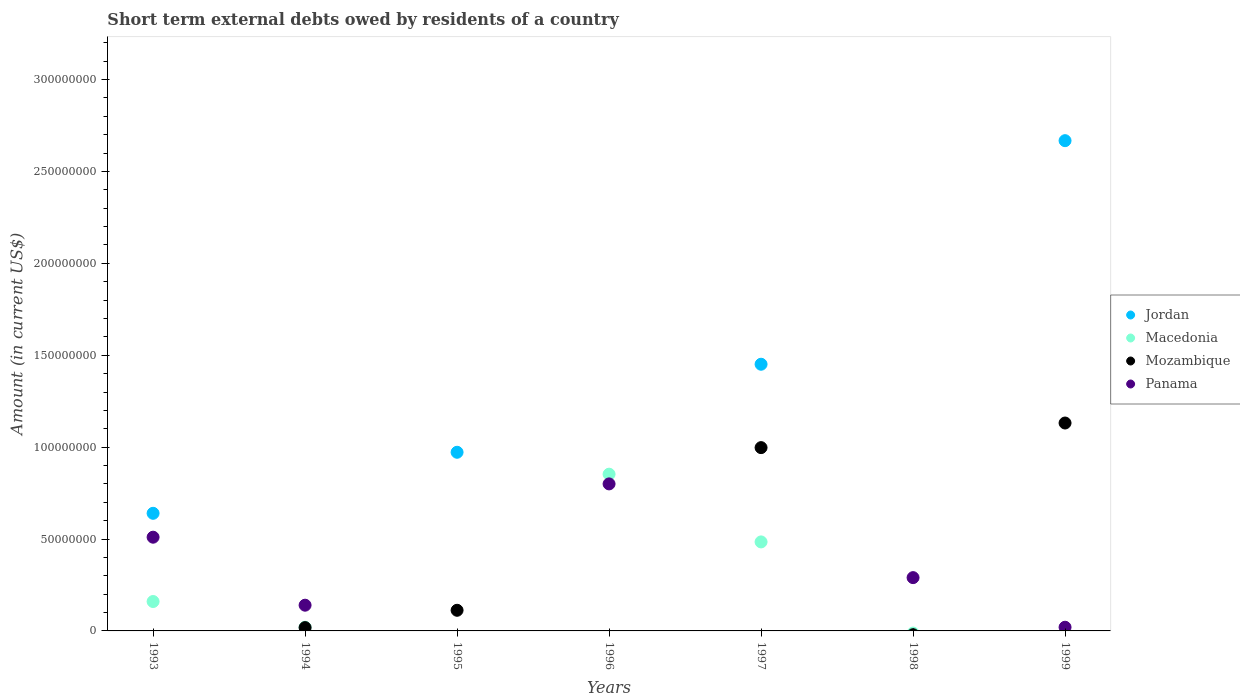How many different coloured dotlines are there?
Provide a succinct answer. 4. Across all years, what is the maximum amount of short-term external debts owed by residents in Panama?
Offer a terse response. 8.00e+07. What is the total amount of short-term external debts owed by residents in Jordan in the graph?
Make the answer very short. 5.73e+08. What is the difference between the amount of short-term external debts owed by residents in Mozambique in 1995 and that in 1997?
Your answer should be very brief. -8.85e+07. What is the difference between the amount of short-term external debts owed by residents in Macedonia in 1994 and the amount of short-term external debts owed by residents in Mozambique in 1999?
Offer a very short reply. -1.11e+08. What is the average amount of short-term external debts owed by residents in Jordan per year?
Ensure brevity in your answer.  8.19e+07. In the year 1995, what is the difference between the amount of short-term external debts owed by residents in Mozambique and amount of short-term external debts owed by residents in Jordan?
Keep it short and to the point. -8.60e+07. Is the difference between the amount of short-term external debts owed by residents in Mozambique in 1995 and 1997 greater than the difference between the amount of short-term external debts owed by residents in Jordan in 1995 and 1997?
Keep it short and to the point. No. What is the difference between the highest and the second highest amount of short-term external debts owed by residents in Jordan?
Keep it short and to the point. 1.22e+08. What is the difference between the highest and the lowest amount of short-term external debts owed by residents in Macedonia?
Offer a very short reply. 8.53e+07. In how many years, is the amount of short-term external debts owed by residents in Jordan greater than the average amount of short-term external debts owed by residents in Jordan taken over all years?
Ensure brevity in your answer.  3. Is the sum of the amount of short-term external debts owed by residents in Panama in 1996 and 1999 greater than the maximum amount of short-term external debts owed by residents in Mozambique across all years?
Give a very brief answer. No. Is it the case that in every year, the sum of the amount of short-term external debts owed by residents in Mozambique and amount of short-term external debts owed by residents in Macedonia  is greater than the amount of short-term external debts owed by residents in Jordan?
Your answer should be compact. No. Does the amount of short-term external debts owed by residents in Mozambique monotonically increase over the years?
Your answer should be compact. No. Is the amount of short-term external debts owed by residents in Mozambique strictly less than the amount of short-term external debts owed by residents in Jordan over the years?
Your answer should be very brief. No. How many dotlines are there?
Ensure brevity in your answer.  4. How many years are there in the graph?
Provide a short and direct response. 7. What is the difference between two consecutive major ticks on the Y-axis?
Offer a very short reply. 5.00e+07. Does the graph contain any zero values?
Provide a succinct answer. Yes. Does the graph contain grids?
Your answer should be compact. No. Where does the legend appear in the graph?
Offer a very short reply. Center right. How are the legend labels stacked?
Make the answer very short. Vertical. What is the title of the graph?
Your response must be concise. Short term external debts owed by residents of a country. Does "Chad" appear as one of the legend labels in the graph?
Give a very brief answer. No. What is the label or title of the X-axis?
Your response must be concise. Years. What is the label or title of the Y-axis?
Provide a short and direct response. Amount (in current US$). What is the Amount (in current US$) of Jordan in 1993?
Offer a terse response. 6.40e+07. What is the Amount (in current US$) of Macedonia in 1993?
Your answer should be compact. 1.60e+07. What is the Amount (in current US$) in Mozambique in 1993?
Make the answer very short. 0. What is the Amount (in current US$) of Panama in 1993?
Your response must be concise. 5.10e+07. What is the Amount (in current US$) of Macedonia in 1994?
Your answer should be compact. 2.00e+06. What is the Amount (in current US$) of Mozambique in 1994?
Offer a terse response. 1.80e+06. What is the Amount (in current US$) of Panama in 1994?
Offer a very short reply. 1.40e+07. What is the Amount (in current US$) of Jordan in 1995?
Provide a succinct answer. 9.72e+07. What is the Amount (in current US$) of Mozambique in 1995?
Provide a succinct answer. 1.12e+07. What is the Amount (in current US$) in Macedonia in 1996?
Ensure brevity in your answer.  8.53e+07. What is the Amount (in current US$) in Mozambique in 1996?
Ensure brevity in your answer.  0. What is the Amount (in current US$) of Panama in 1996?
Your response must be concise. 8.00e+07. What is the Amount (in current US$) of Jordan in 1997?
Offer a very short reply. 1.45e+08. What is the Amount (in current US$) in Macedonia in 1997?
Offer a terse response. 4.84e+07. What is the Amount (in current US$) in Mozambique in 1997?
Your response must be concise. 9.97e+07. What is the Amount (in current US$) of Mozambique in 1998?
Your answer should be compact. 0. What is the Amount (in current US$) of Panama in 1998?
Your answer should be very brief. 2.90e+07. What is the Amount (in current US$) in Jordan in 1999?
Your response must be concise. 2.67e+08. What is the Amount (in current US$) in Macedonia in 1999?
Make the answer very short. 0. What is the Amount (in current US$) of Mozambique in 1999?
Your answer should be compact. 1.13e+08. Across all years, what is the maximum Amount (in current US$) of Jordan?
Offer a very short reply. 2.67e+08. Across all years, what is the maximum Amount (in current US$) in Macedonia?
Make the answer very short. 8.53e+07. Across all years, what is the maximum Amount (in current US$) in Mozambique?
Your response must be concise. 1.13e+08. Across all years, what is the maximum Amount (in current US$) of Panama?
Provide a succinct answer. 8.00e+07. Across all years, what is the minimum Amount (in current US$) of Mozambique?
Give a very brief answer. 0. Across all years, what is the minimum Amount (in current US$) in Panama?
Provide a succinct answer. 0. What is the total Amount (in current US$) of Jordan in the graph?
Offer a terse response. 5.73e+08. What is the total Amount (in current US$) of Macedonia in the graph?
Provide a short and direct response. 1.52e+08. What is the total Amount (in current US$) of Mozambique in the graph?
Your answer should be compact. 2.26e+08. What is the total Amount (in current US$) of Panama in the graph?
Provide a short and direct response. 1.76e+08. What is the difference between the Amount (in current US$) in Macedonia in 1993 and that in 1994?
Give a very brief answer. 1.40e+07. What is the difference between the Amount (in current US$) in Panama in 1993 and that in 1994?
Your response must be concise. 3.70e+07. What is the difference between the Amount (in current US$) of Jordan in 1993 and that in 1995?
Offer a terse response. -3.32e+07. What is the difference between the Amount (in current US$) of Macedonia in 1993 and that in 1996?
Provide a succinct answer. -6.93e+07. What is the difference between the Amount (in current US$) of Panama in 1993 and that in 1996?
Keep it short and to the point. -2.90e+07. What is the difference between the Amount (in current US$) of Jordan in 1993 and that in 1997?
Give a very brief answer. -8.11e+07. What is the difference between the Amount (in current US$) in Macedonia in 1993 and that in 1997?
Your answer should be compact. -3.24e+07. What is the difference between the Amount (in current US$) of Panama in 1993 and that in 1998?
Offer a terse response. 2.20e+07. What is the difference between the Amount (in current US$) of Jordan in 1993 and that in 1999?
Your answer should be very brief. -2.03e+08. What is the difference between the Amount (in current US$) of Panama in 1993 and that in 1999?
Provide a succinct answer. 4.90e+07. What is the difference between the Amount (in current US$) in Mozambique in 1994 and that in 1995?
Provide a short and direct response. -9.43e+06. What is the difference between the Amount (in current US$) of Macedonia in 1994 and that in 1996?
Your answer should be compact. -8.33e+07. What is the difference between the Amount (in current US$) of Panama in 1994 and that in 1996?
Offer a very short reply. -6.60e+07. What is the difference between the Amount (in current US$) of Macedonia in 1994 and that in 1997?
Make the answer very short. -4.64e+07. What is the difference between the Amount (in current US$) in Mozambique in 1994 and that in 1997?
Ensure brevity in your answer.  -9.79e+07. What is the difference between the Amount (in current US$) of Panama in 1994 and that in 1998?
Your answer should be compact. -1.50e+07. What is the difference between the Amount (in current US$) in Mozambique in 1994 and that in 1999?
Offer a very short reply. -1.11e+08. What is the difference between the Amount (in current US$) of Jordan in 1995 and that in 1997?
Your answer should be very brief. -4.79e+07. What is the difference between the Amount (in current US$) in Mozambique in 1995 and that in 1997?
Your answer should be very brief. -8.85e+07. What is the difference between the Amount (in current US$) of Jordan in 1995 and that in 1999?
Provide a short and direct response. -1.70e+08. What is the difference between the Amount (in current US$) in Mozambique in 1995 and that in 1999?
Keep it short and to the point. -1.02e+08. What is the difference between the Amount (in current US$) of Macedonia in 1996 and that in 1997?
Your answer should be very brief. 3.69e+07. What is the difference between the Amount (in current US$) in Panama in 1996 and that in 1998?
Offer a very short reply. 5.10e+07. What is the difference between the Amount (in current US$) of Panama in 1996 and that in 1999?
Make the answer very short. 7.80e+07. What is the difference between the Amount (in current US$) in Jordan in 1997 and that in 1999?
Make the answer very short. -1.22e+08. What is the difference between the Amount (in current US$) of Mozambique in 1997 and that in 1999?
Your response must be concise. -1.34e+07. What is the difference between the Amount (in current US$) of Panama in 1998 and that in 1999?
Ensure brevity in your answer.  2.70e+07. What is the difference between the Amount (in current US$) of Jordan in 1993 and the Amount (in current US$) of Macedonia in 1994?
Offer a terse response. 6.20e+07. What is the difference between the Amount (in current US$) in Jordan in 1993 and the Amount (in current US$) in Mozambique in 1994?
Keep it short and to the point. 6.22e+07. What is the difference between the Amount (in current US$) of Jordan in 1993 and the Amount (in current US$) of Panama in 1994?
Provide a succinct answer. 5.00e+07. What is the difference between the Amount (in current US$) in Macedonia in 1993 and the Amount (in current US$) in Mozambique in 1994?
Give a very brief answer. 1.42e+07. What is the difference between the Amount (in current US$) in Macedonia in 1993 and the Amount (in current US$) in Panama in 1994?
Your answer should be very brief. 2.00e+06. What is the difference between the Amount (in current US$) in Jordan in 1993 and the Amount (in current US$) in Mozambique in 1995?
Keep it short and to the point. 5.28e+07. What is the difference between the Amount (in current US$) of Macedonia in 1993 and the Amount (in current US$) of Mozambique in 1995?
Offer a very short reply. 4.77e+06. What is the difference between the Amount (in current US$) of Jordan in 1993 and the Amount (in current US$) of Macedonia in 1996?
Keep it short and to the point. -2.13e+07. What is the difference between the Amount (in current US$) of Jordan in 1993 and the Amount (in current US$) of Panama in 1996?
Your response must be concise. -1.60e+07. What is the difference between the Amount (in current US$) in Macedonia in 1993 and the Amount (in current US$) in Panama in 1996?
Make the answer very short. -6.40e+07. What is the difference between the Amount (in current US$) of Jordan in 1993 and the Amount (in current US$) of Macedonia in 1997?
Provide a succinct answer. 1.56e+07. What is the difference between the Amount (in current US$) of Jordan in 1993 and the Amount (in current US$) of Mozambique in 1997?
Provide a short and direct response. -3.57e+07. What is the difference between the Amount (in current US$) of Macedonia in 1993 and the Amount (in current US$) of Mozambique in 1997?
Give a very brief answer. -8.37e+07. What is the difference between the Amount (in current US$) in Jordan in 1993 and the Amount (in current US$) in Panama in 1998?
Provide a short and direct response. 3.50e+07. What is the difference between the Amount (in current US$) of Macedonia in 1993 and the Amount (in current US$) of Panama in 1998?
Give a very brief answer. -1.30e+07. What is the difference between the Amount (in current US$) of Jordan in 1993 and the Amount (in current US$) of Mozambique in 1999?
Your answer should be very brief. -4.91e+07. What is the difference between the Amount (in current US$) in Jordan in 1993 and the Amount (in current US$) in Panama in 1999?
Provide a succinct answer. 6.20e+07. What is the difference between the Amount (in current US$) of Macedonia in 1993 and the Amount (in current US$) of Mozambique in 1999?
Your answer should be very brief. -9.71e+07. What is the difference between the Amount (in current US$) of Macedonia in 1993 and the Amount (in current US$) of Panama in 1999?
Provide a short and direct response. 1.40e+07. What is the difference between the Amount (in current US$) in Macedonia in 1994 and the Amount (in current US$) in Mozambique in 1995?
Ensure brevity in your answer.  -9.23e+06. What is the difference between the Amount (in current US$) of Macedonia in 1994 and the Amount (in current US$) of Panama in 1996?
Give a very brief answer. -7.80e+07. What is the difference between the Amount (in current US$) of Mozambique in 1994 and the Amount (in current US$) of Panama in 1996?
Keep it short and to the point. -7.82e+07. What is the difference between the Amount (in current US$) in Macedonia in 1994 and the Amount (in current US$) in Mozambique in 1997?
Offer a terse response. -9.77e+07. What is the difference between the Amount (in current US$) of Macedonia in 1994 and the Amount (in current US$) of Panama in 1998?
Provide a short and direct response. -2.70e+07. What is the difference between the Amount (in current US$) of Mozambique in 1994 and the Amount (in current US$) of Panama in 1998?
Offer a very short reply. -2.72e+07. What is the difference between the Amount (in current US$) of Macedonia in 1994 and the Amount (in current US$) of Mozambique in 1999?
Provide a succinct answer. -1.11e+08. What is the difference between the Amount (in current US$) in Jordan in 1995 and the Amount (in current US$) in Macedonia in 1996?
Provide a succinct answer. 1.19e+07. What is the difference between the Amount (in current US$) in Jordan in 1995 and the Amount (in current US$) in Panama in 1996?
Provide a short and direct response. 1.72e+07. What is the difference between the Amount (in current US$) in Mozambique in 1995 and the Amount (in current US$) in Panama in 1996?
Keep it short and to the point. -6.88e+07. What is the difference between the Amount (in current US$) of Jordan in 1995 and the Amount (in current US$) of Macedonia in 1997?
Your response must be concise. 4.88e+07. What is the difference between the Amount (in current US$) of Jordan in 1995 and the Amount (in current US$) of Mozambique in 1997?
Keep it short and to the point. -2.53e+06. What is the difference between the Amount (in current US$) in Jordan in 1995 and the Amount (in current US$) in Panama in 1998?
Ensure brevity in your answer.  6.82e+07. What is the difference between the Amount (in current US$) of Mozambique in 1995 and the Amount (in current US$) of Panama in 1998?
Ensure brevity in your answer.  -1.78e+07. What is the difference between the Amount (in current US$) in Jordan in 1995 and the Amount (in current US$) in Mozambique in 1999?
Ensure brevity in your answer.  -1.59e+07. What is the difference between the Amount (in current US$) in Jordan in 1995 and the Amount (in current US$) in Panama in 1999?
Your answer should be compact. 9.52e+07. What is the difference between the Amount (in current US$) in Mozambique in 1995 and the Amount (in current US$) in Panama in 1999?
Offer a terse response. 9.23e+06. What is the difference between the Amount (in current US$) in Macedonia in 1996 and the Amount (in current US$) in Mozambique in 1997?
Make the answer very short. -1.44e+07. What is the difference between the Amount (in current US$) of Macedonia in 1996 and the Amount (in current US$) of Panama in 1998?
Your response must be concise. 5.63e+07. What is the difference between the Amount (in current US$) of Macedonia in 1996 and the Amount (in current US$) of Mozambique in 1999?
Ensure brevity in your answer.  -2.78e+07. What is the difference between the Amount (in current US$) in Macedonia in 1996 and the Amount (in current US$) in Panama in 1999?
Your answer should be compact. 8.33e+07. What is the difference between the Amount (in current US$) in Jordan in 1997 and the Amount (in current US$) in Panama in 1998?
Your answer should be compact. 1.16e+08. What is the difference between the Amount (in current US$) in Macedonia in 1997 and the Amount (in current US$) in Panama in 1998?
Make the answer very short. 1.94e+07. What is the difference between the Amount (in current US$) of Mozambique in 1997 and the Amount (in current US$) of Panama in 1998?
Provide a short and direct response. 7.07e+07. What is the difference between the Amount (in current US$) in Jordan in 1997 and the Amount (in current US$) in Mozambique in 1999?
Offer a very short reply. 3.20e+07. What is the difference between the Amount (in current US$) in Jordan in 1997 and the Amount (in current US$) in Panama in 1999?
Your response must be concise. 1.43e+08. What is the difference between the Amount (in current US$) of Macedonia in 1997 and the Amount (in current US$) of Mozambique in 1999?
Ensure brevity in your answer.  -6.47e+07. What is the difference between the Amount (in current US$) of Macedonia in 1997 and the Amount (in current US$) of Panama in 1999?
Keep it short and to the point. 4.64e+07. What is the difference between the Amount (in current US$) of Mozambique in 1997 and the Amount (in current US$) of Panama in 1999?
Make the answer very short. 9.77e+07. What is the average Amount (in current US$) in Jordan per year?
Ensure brevity in your answer.  8.19e+07. What is the average Amount (in current US$) in Macedonia per year?
Give a very brief answer. 2.17e+07. What is the average Amount (in current US$) in Mozambique per year?
Make the answer very short. 3.23e+07. What is the average Amount (in current US$) of Panama per year?
Offer a terse response. 2.51e+07. In the year 1993, what is the difference between the Amount (in current US$) of Jordan and Amount (in current US$) of Macedonia?
Provide a short and direct response. 4.80e+07. In the year 1993, what is the difference between the Amount (in current US$) in Jordan and Amount (in current US$) in Panama?
Provide a succinct answer. 1.30e+07. In the year 1993, what is the difference between the Amount (in current US$) in Macedonia and Amount (in current US$) in Panama?
Ensure brevity in your answer.  -3.50e+07. In the year 1994, what is the difference between the Amount (in current US$) of Macedonia and Amount (in current US$) of Panama?
Your answer should be compact. -1.20e+07. In the year 1994, what is the difference between the Amount (in current US$) of Mozambique and Amount (in current US$) of Panama?
Offer a terse response. -1.22e+07. In the year 1995, what is the difference between the Amount (in current US$) in Jordan and Amount (in current US$) in Mozambique?
Provide a succinct answer. 8.60e+07. In the year 1996, what is the difference between the Amount (in current US$) in Macedonia and Amount (in current US$) in Panama?
Your response must be concise. 5.29e+06. In the year 1997, what is the difference between the Amount (in current US$) of Jordan and Amount (in current US$) of Macedonia?
Offer a very short reply. 9.67e+07. In the year 1997, what is the difference between the Amount (in current US$) of Jordan and Amount (in current US$) of Mozambique?
Keep it short and to the point. 4.54e+07. In the year 1997, what is the difference between the Amount (in current US$) of Macedonia and Amount (in current US$) of Mozambique?
Make the answer very short. -5.13e+07. In the year 1999, what is the difference between the Amount (in current US$) in Jordan and Amount (in current US$) in Mozambique?
Provide a short and direct response. 1.54e+08. In the year 1999, what is the difference between the Amount (in current US$) of Jordan and Amount (in current US$) of Panama?
Your response must be concise. 2.65e+08. In the year 1999, what is the difference between the Amount (in current US$) in Mozambique and Amount (in current US$) in Panama?
Give a very brief answer. 1.11e+08. What is the ratio of the Amount (in current US$) in Panama in 1993 to that in 1994?
Keep it short and to the point. 3.64. What is the ratio of the Amount (in current US$) of Jordan in 1993 to that in 1995?
Provide a short and direct response. 0.66. What is the ratio of the Amount (in current US$) of Macedonia in 1993 to that in 1996?
Offer a very short reply. 0.19. What is the ratio of the Amount (in current US$) of Panama in 1993 to that in 1996?
Offer a very short reply. 0.64. What is the ratio of the Amount (in current US$) of Jordan in 1993 to that in 1997?
Offer a very short reply. 0.44. What is the ratio of the Amount (in current US$) of Macedonia in 1993 to that in 1997?
Your response must be concise. 0.33. What is the ratio of the Amount (in current US$) in Panama in 1993 to that in 1998?
Keep it short and to the point. 1.76. What is the ratio of the Amount (in current US$) of Jordan in 1993 to that in 1999?
Make the answer very short. 0.24. What is the ratio of the Amount (in current US$) in Mozambique in 1994 to that in 1995?
Your answer should be compact. 0.16. What is the ratio of the Amount (in current US$) of Macedonia in 1994 to that in 1996?
Your response must be concise. 0.02. What is the ratio of the Amount (in current US$) of Panama in 1994 to that in 1996?
Your answer should be compact. 0.17. What is the ratio of the Amount (in current US$) in Macedonia in 1994 to that in 1997?
Make the answer very short. 0.04. What is the ratio of the Amount (in current US$) of Mozambique in 1994 to that in 1997?
Offer a very short reply. 0.02. What is the ratio of the Amount (in current US$) in Panama in 1994 to that in 1998?
Your answer should be very brief. 0.48. What is the ratio of the Amount (in current US$) of Mozambique in 1994 to that in 1999?
Provide a succinct answer. 0.02. What is the ratio of the Amount (in current US$) in Jordan in 1995 to that in 1997?
Provide a short and direct response. 0.67. What is the ratio of the Amount (in current US$) in Mozambique in 1995 to that in 1997?
Provide a short and direct response. 0.11. What is the ratio of the Amount (in current US$) in Jordan in 1995 to that in 1999?
Offer a very short reply. 0.36. What is the ratio of the Amount (in current US$) of Mozambique in 1995 to that in 1999?
Your answer should be very brief. 0.1. What is the ratio of the Amount (in current US$) in Macedonia in 1996 to that in 1997?
Provide a succinct answer. 1.76. What is the ratio of the Amount (in current US$) in Panama in 1996 to that in 1998?
Make the answer very short. 2.76. What is the ratio of the Amount (in current US$) in Panama in 1996 to that in 1999?
Your response must be concise. 40. What is the ratio of the Amount (in current US$) of Jordan in 1997 to that in 1999?
Your answer should be very brief. 0.54. What is the ratio of the Amount (in current US$) in Mozambique in 1997 to that in 1999?
Ensure brevity in your answer.  0.88. What is the ratio of the Amount (in current US$) in Panama in 1998 to that in 1999?
Keep it short and to the point. 14.5. What is the difference between the highest and the second highest Amount (in current US$) in Jordan?
Your answer should be very brief. 1.22e+08. What is the difference between the highest and the second highest Amount (in current US$) in Macedonia?
Offer a very short reply. 3.69e+07. What is the difference between the highest and the second highest Amount (in current US$) of Mozambique?
Offer a very short reply. 1.34e+07. What is the difference between the highest and the second highest Amount (in current US$) in Panama?
Your answer should be compact. 2.90e+07. What is the difference between the highest and the lowest Amount (in current US$) of Jordan?
Provide a succinct answer. 2.67e+08. What is the difference between the highest and the lowest Amount (in current US$) of Macedonia?
Your answer should be very brief. 8.53e+07. What is the difference between the highest and the lowest Amount (in current US$) of Mozambique?
Your response must be concise. 1.13e+08. What is the difference between the highest and the lowest Amount (in current US$) of Panama?
Your answer should be compact. 8.00e+07. 